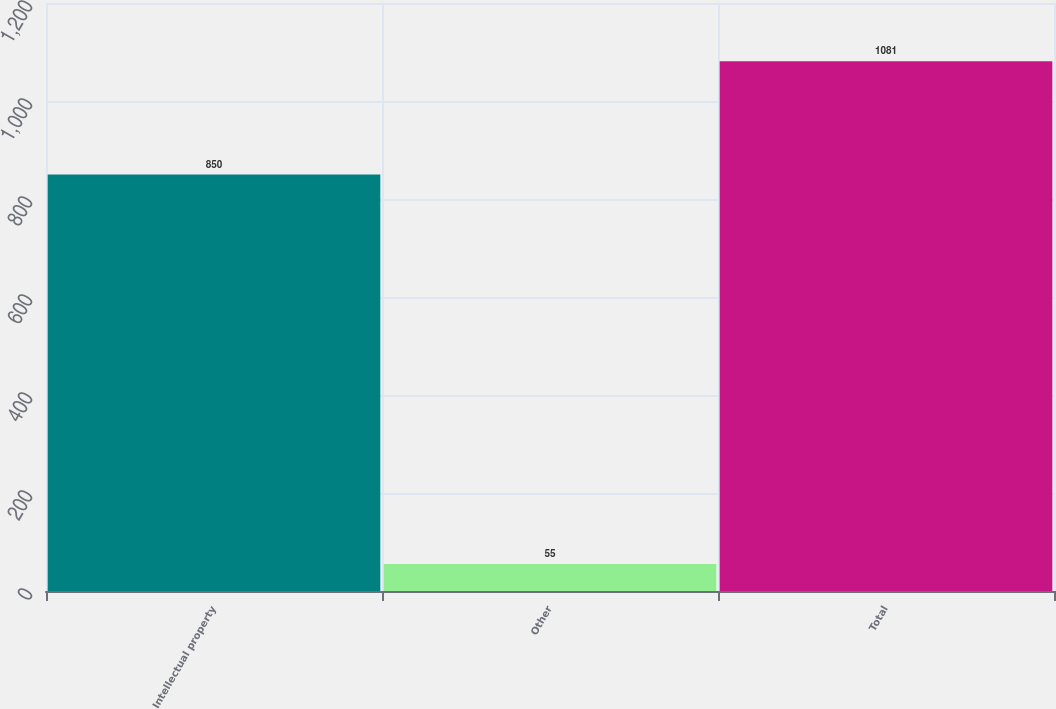<chart> <loc_0><loc_0><loc_500><loc_500><bar_chart><fcel>Intellectual property<fcel>Other<fcel>Total<nl><fcel>850<fcel>55<fcel>1081<nl></chart> 